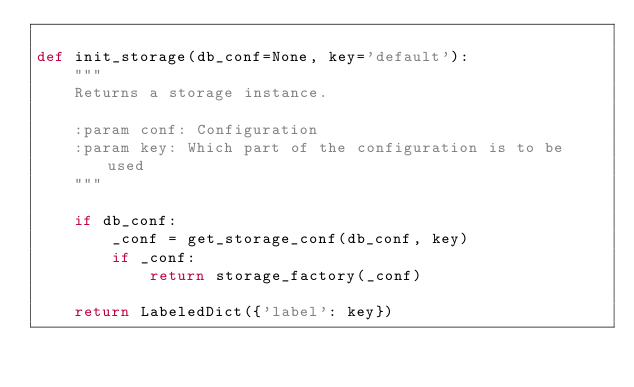<code> <loc_0><loc_0><loc_500><loc_500><_Python_>
def init_storage(db_conf=None, key='default'):
    """
    Returns a storage instance.

    :param conf: Configuration
    :param key: Which part of the configuration is to be used
    """

    if db_conf:
        _conf = get_storage_conf(db_conf, key)
        if _conf:
            return storage_factory(_conf)

    return LabeledDict({'label': key})
</code> 